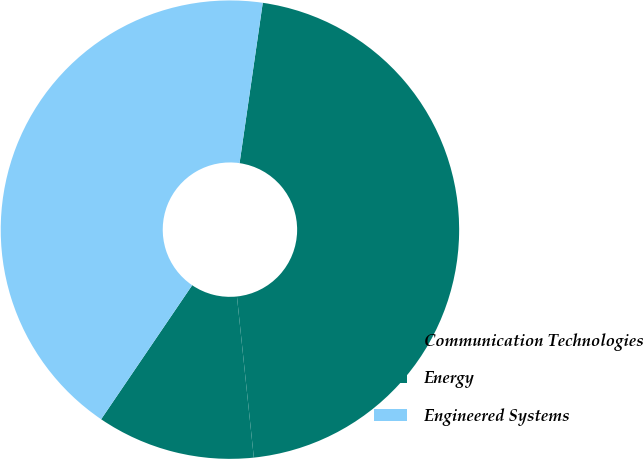<chart> <loc_0><loc_0><loc_500><loc_500><pie_chart><fcel>Communication Technologies<fcel>Energy<fcel>Engineered Systems<nl><fcel>11.16%<fcel>46.05%<fcel>42.79%<nl></chart> 